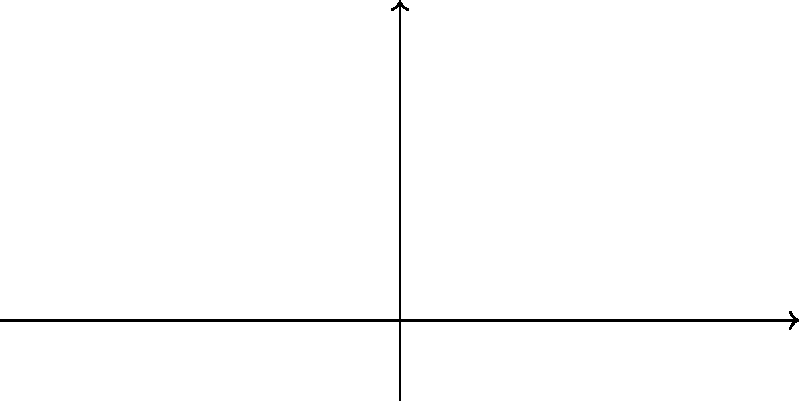In an air traffic control scenario, three aircraft positions A(2,4), B(6,2), and C(8,6) form a triangle in the airspace. If these positions are reflected across the y-axis, what are the coordinates of the reflected aircraft positions A', B', and C'? To reflect points across the y-axis, we need to change the sign of the x-coordinate while keeping the y-coordinate the same. This is because the y-axis acts as a mirror line in this reflection.

Let's reflect each point:

1. For point A(2,4):
   - Change the sign of x: 2 becomes -2
   - Keep y the same: 4
   A' = (-2,4)

2. For point B(6,2):
   - Change the sign of x: 6 becomes -6
   - Keep y the same: 2
   B' = (-6,2)

3. For point C(8,6):
   - Change the sign of x: 8 becomes -8
   - Keep y the same: 6
   C' = (-8,6)

The reflection across the y-axis essentially flips the triangle from the right side of the y-axis to the left side, maintaining the same distance from the y-axis for each point.
Answer: A'(-2,4), B'(-6,2), C'(-8,6) 